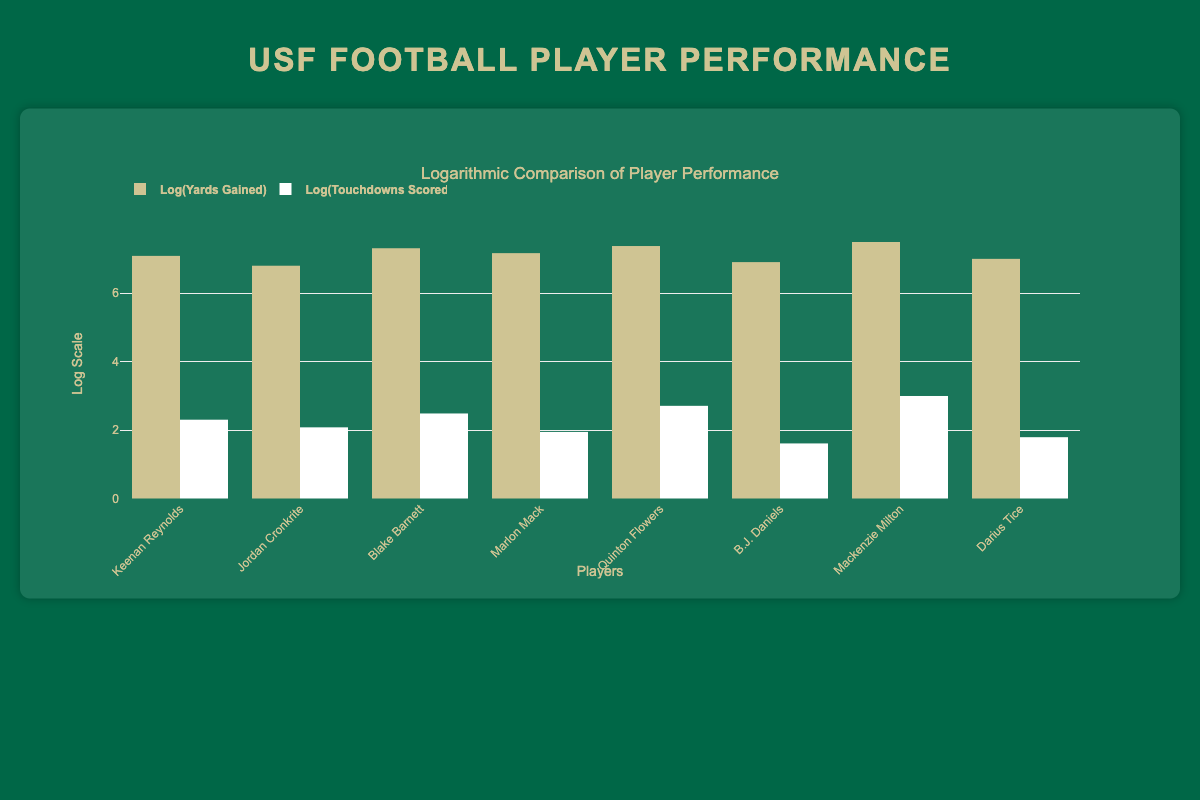What is the total number of touchdowns scored by Quinton Flowers in the 2019 season? The table indicates that Quinton Flowers scored 15 touchdowns in the 2019 season as stated in the data for that player.
Answer: 15 Which player had the highest yards gained in a single season? Looking at the data, Mackenzie Milton had the highest yards gained with 1800 in the 2017 season, which is greater than any other player listed.
Answer: Mackenzie Milton What is the average number of touchdowns scored by the players during the 2019 and 2021 seasons combined? For the 2019 season, Quinton Flowers scored 15 and Marlon Mack scored 7, totaling 22. In 2021, Keenan Reynolds scored 10 and Jordan Cronkrite scored 8, totaling 18. Combining these gives 22 + 18 = 40 touchdowns for the two seasons. There are 4 players total, so the average is 40 / 4 = 10.
Answer: 10 Did any player score more than 20 touchdowns in a season? By examining the table, the highest number of touchdowns scored by a player is 20, achieved by Mackenzie Milton in the 2017 season, hence no player scored more than that.
Answer: No How many more yards did Blake Barnett gain compared to Darius Tice? Blake Barnett gained 1500 yards in 2020, while Darius Tice gained 1100 yards in 2016. The difference is 1500 - 1100 = 400 yards.
Answer: 400 Which season had the highest average yards gained by USF players? For the 2019 season, the total yards gained by players are Quinton Flowers with 1600 and Marlon Mack with 1300, totaling 2900 yards for 2 players. For the 2021 season, we have Keenan Reynolds with 1200 and Jordan Cronkrite with 900, totaling 2100 yards for 2 players. Therefore, the average for 2019 is 2900 / 2 = 1450, and for 2021 is 2100 / 2 = 1050. The highest average is 1450 for the 2019 season.
Answer: 2019 Is Keenan Reynolds the only player in the 2021 season with double-digit touchdowns? According to the table, Keenan Reynolds scored 10 touchdowns and Jordan Cronkrite scored 8 touchdowns in 2021. This confirms that Keenan Reynolds is the only player with double-digit touchdowns in that season.
Answer: Yes What is the total yards gained by all players listed in the 2018 and 2020 seasons? In 2018, B.J. Daniels gained 1000 yards, and in 2020, Blake Barnett gained 1500 yards. The total yards gained are 1000 + 1500 = 2500 yards for both seasons combined.
Answer: 2500 